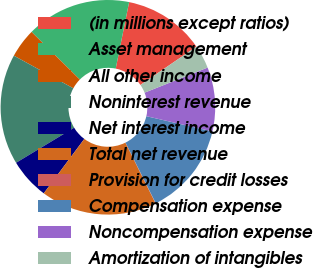Convert chart. <chart><loc_0><loc_0><loc_500><loc_500><pie_chart><fcel>(in millions except ratios)<fcel>Asset management<fcel>All other income<fcel>Noninterest revenue<fcel>Net interest income<fcel>Total net revenue<fcel>Provision for credit losses<fcel>Compensation expense<fcel>Noncompensation expense<fcel>Amortization of intangibles<nl><fcel>12.27%<fcel>15.77%<fcel>4.41%<fcel>16.64%<fcel>6.15%<fcel>17.52%<fcel>0.04%<fcel>14.02%<fcel>9.65%<fcel>3.53%<nl></chart> 